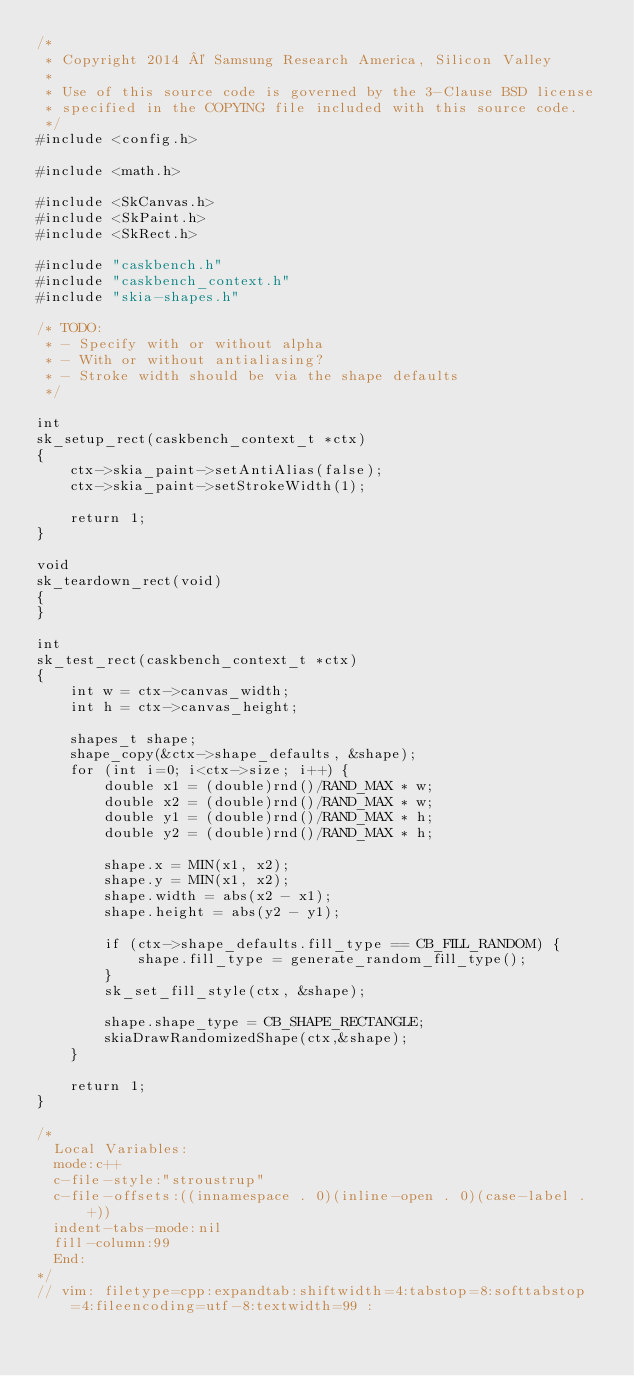Convert code to text. <code><loc_0><loc_0><loc_500><loc_500><_C++_>/*
 * Copyright 2014 © Samsung Research America, Silicon Valley
 *
 * Use of this source code is governed by the 3-Clause BSD license
 * specified in the COPYING file included with this source code.
 */
#include <config.h>

#include <math.h>

#include <SkCanvas.h>
#include <SkPaint.h>
#include <SkRect.h>

#include "caskbench.h"
#include "caskbench_context.h"
#include "skia-shapes.h"

/* TODO:
 * - Specify with or without alpha
 * - With or without antialiasing?
 * - Stroke width should be via the shape defaults
 */

int
sk_setup_rect(caskbench_context_t *ctx)
{
    ctx->skia_paint->setAntiAlias(false);
    ctx->skia_paint->setStrokeWidth(1);

    return 1;
}

void
sk_teardown_rect(void)
{
}

int
sk_test_rect(caskbench_context_t *ctx)
{
    int w = ctx->canvas_width;
    int h = ctx->canvas_height;

    shapes_t shape;
    shape_copy(&ctx->shape_defaults, &shape);
    for (int i=0; i<ctx->size; i++) {
        double x1 = (double)rnd()/RAND_MAX * w;
        double x2 = (double)rnd()/RAND_MAX * w;
        double y1 = (double)rnd()/RAND_MAX * h;
        double y2 = (double)rnd()/RAND_MAX * h;

        shape.x = MIN(x1, x2);
        shape.y = MIN(x1, x2);
        shape.width = abs(x2 - x1);
        shape.height = abs(y2 - y1);

        if (ctx->shape_defaults.fill_type == CB_FILL_RANDOM) {
            shape.fill_type = generate_random_fill_type();
        }
        sk_set_fill_style(ctx, &shape);

        shape.shape_type = CB_SHAPE_RECTANGLE;
        skiaDrawRandomizedShape(ctx,&shape);
    }

    return 1;
}

/*
  Local Variables:
  mode:c++
  c-file-style:"stroustrup"
  c-file-offsets:((innamespace . 0)(inline-open . 0)(case-label . +))
  indent-tabs-mode:nil
  fill-column:99
  End:
*/
// vim: filetype=cpp:expandtab:shiftwidth=4:tabstop=8:softtabstop=4:fileencoding=utf-8:textwidth=99 :
</code> 